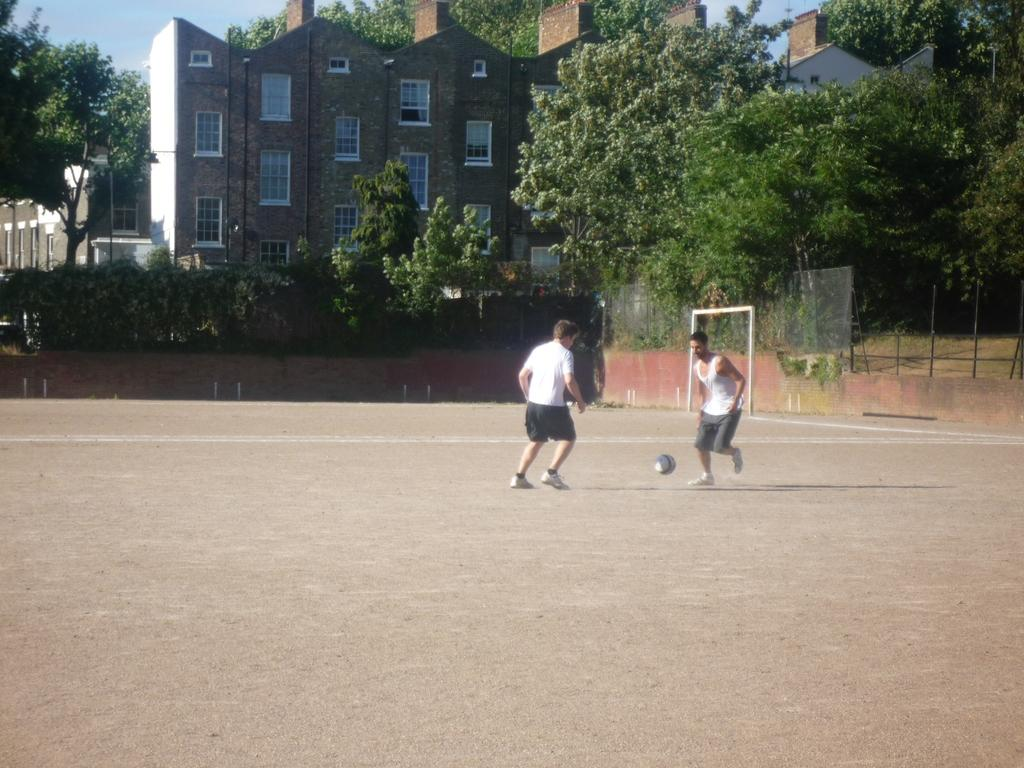How many people are in the image? There are two men in the image. What are the men doing in the image? The men are playing football. Where is the football game taking place? The football game is taking place on the ground. What can be seen in the background of the image? There are trees, buildings, windows, a fence, and the sky visible in the background of the image. What type of bait is being used by the men in the image? There is no mention of bait or fishing in the image; the men are playing football. What metal object can be seen in the image? There is no specific metal object mentioned in the image; however, the fence in the background could be made of metal. 